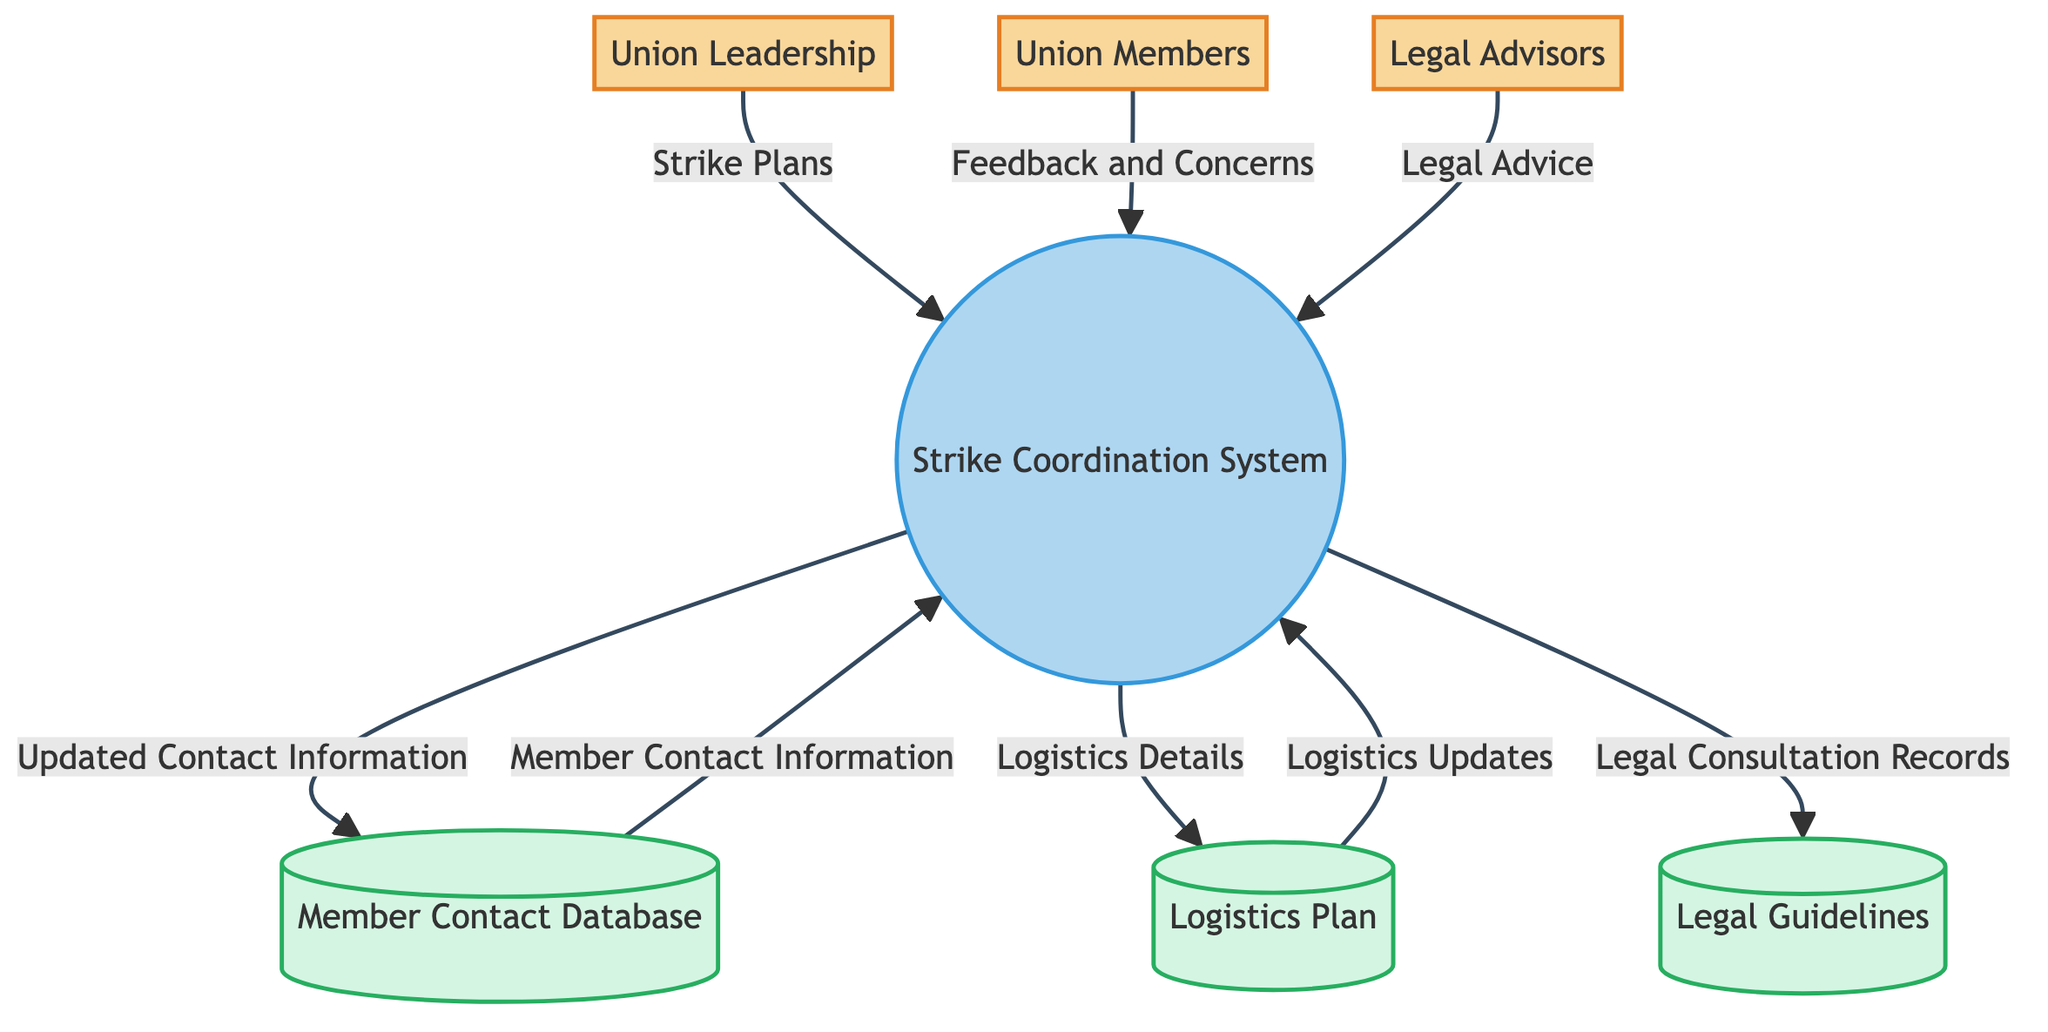What are the entities involved in the strike coordination process? The diagram lists three external entities: Union Leadership, Union Members, and Legal Advisors. These represent the key participants in the coordination process.
Answer: Union Leadership, Union Members, Legal Advisors How many data stores are present in the diagram? The diagram shows three data stores: Member Contact Database, Logistics Plan, and Legal Guidelines. Counting these gives a total of three data stores.
Answer: 3 What data flows from Legal Advisors to the Strike Coordination System? According to the diagram, the data flow from Legal Advisors to the Strike Coordination System is labeled as "Legal Advice." This represents the information provided by legal experts to support the coordination process.
Answer: Legal Advice What type of data is sent from the Strike Coordination System to the Logistics Plan? The Strike Coordination System sends "Logistics Details" to the Logistics Plan, indicating the specifics about the logistics related to strike actions.
Answer: Logistics Details Which data store receives updated contact information? The diagram indicates that the Member Contact Database receives updated contact information from the Strike Coordination System. This reflects the management of membership details during the strike coordination process.
Answer: Member Contact Database What is the initial source of feedback and concerns in the strike coordination process? The initial source of feedback and concerns in the process is the Union Members, as indicated by the data flow labeled "Feedback and Concerns" directed to the Strike Coordination System.
Answer: Union Members What is the relationship between the Strike Coordination System and Member Contact Database? The relationship is established by the data flow where the Strike Coordination System sends updated contact information to the Member Contact Database. This shows how data about members is managed and updated.
Answer: Updated Contact Information Which entity provides legal advice to the Strike Coordination System? The Legal Advisors are the entity that provides legal advice to the Strike Coordination System, as shown by the directed flow of data labeled "Legal Advice."
Answer: Legal Advisors How does the Strike Coordination System use the Logistics Plan? The Strike Coordination System utilizes the Logistics Plan by sending "Logistics Details" to it. This is essential for planning the logistics of the strike actions effectively.
Answer: Logistics Details 